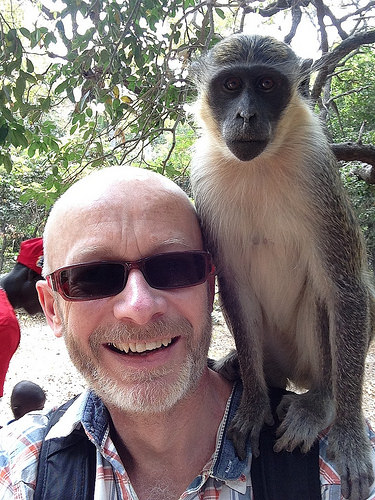<image>
Can you confirm if the monkey is on the backpack? Yes. Looking at the image, I can see the monkey is positioned on top of the backpack, with the backpack providing support. Is there a monkey on the man? Yes. Looking at the image, I can see the monkey is positioned on top of the man, with the man providing support. Is there a monkey to the left of the man? No. The monkey is not to the left of the man. From this viewpoint, they have a different horizontal relationship. 